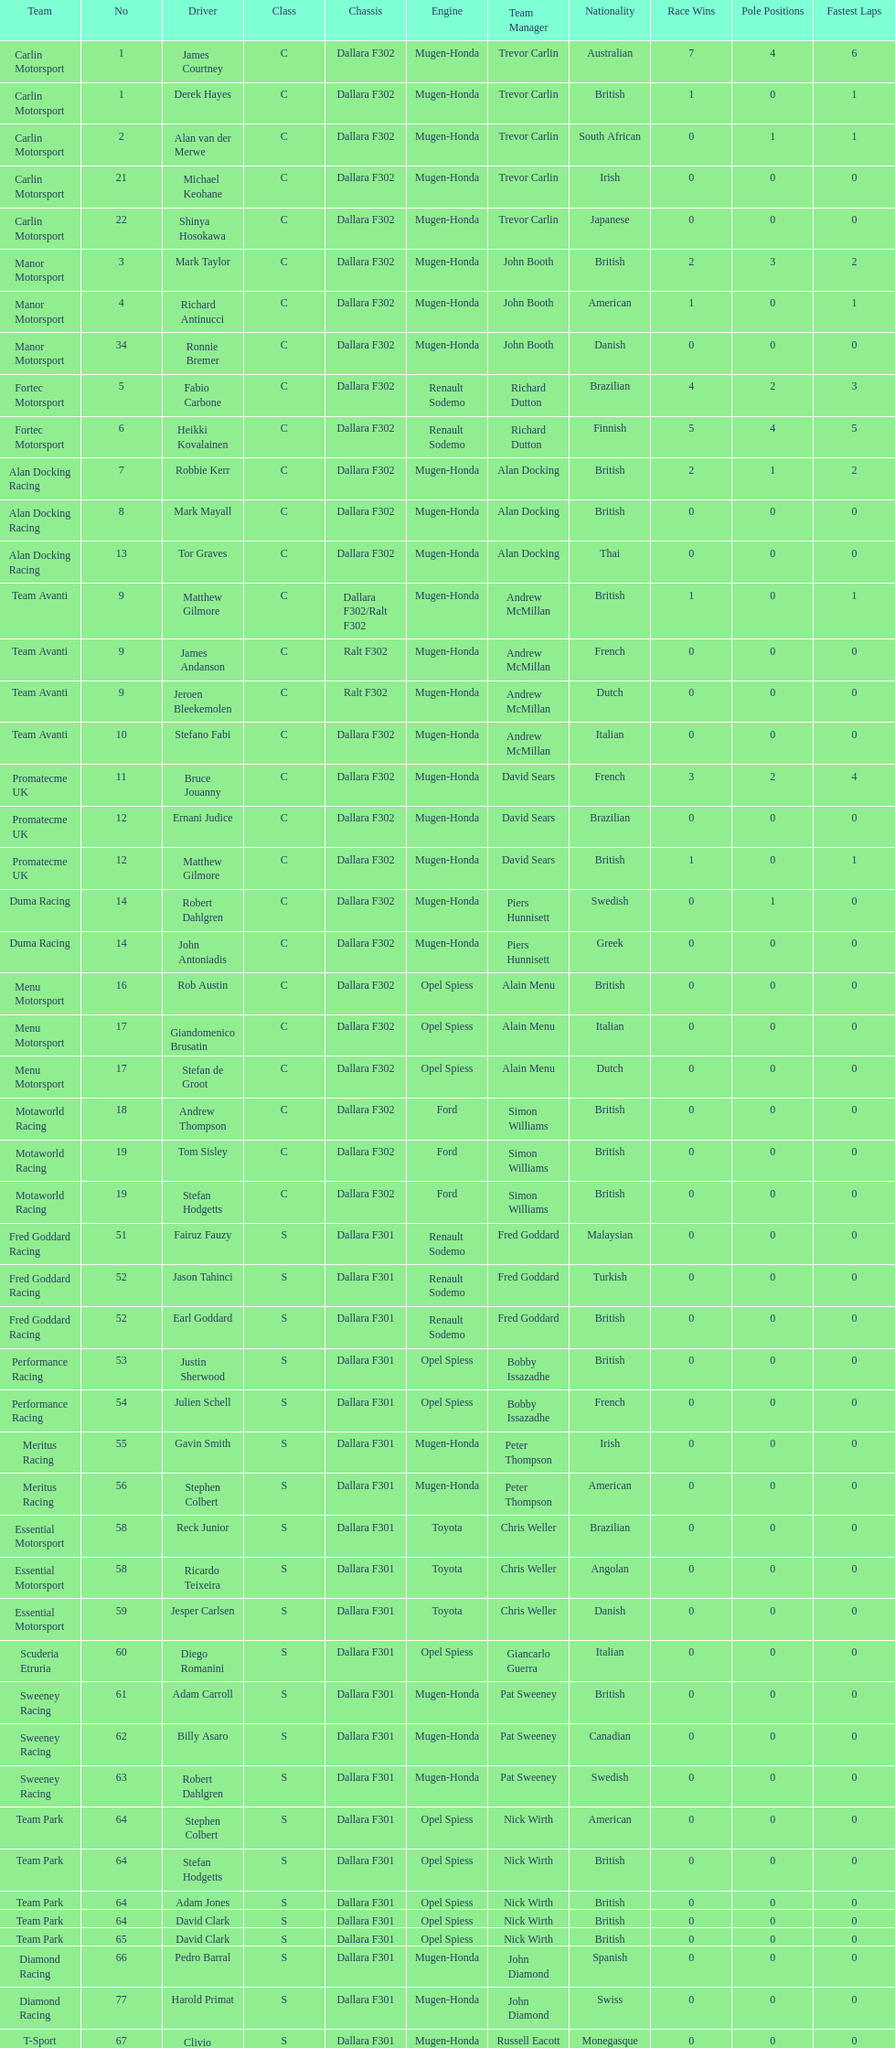What is the number of teams that had drivers all from the same country? 4. 